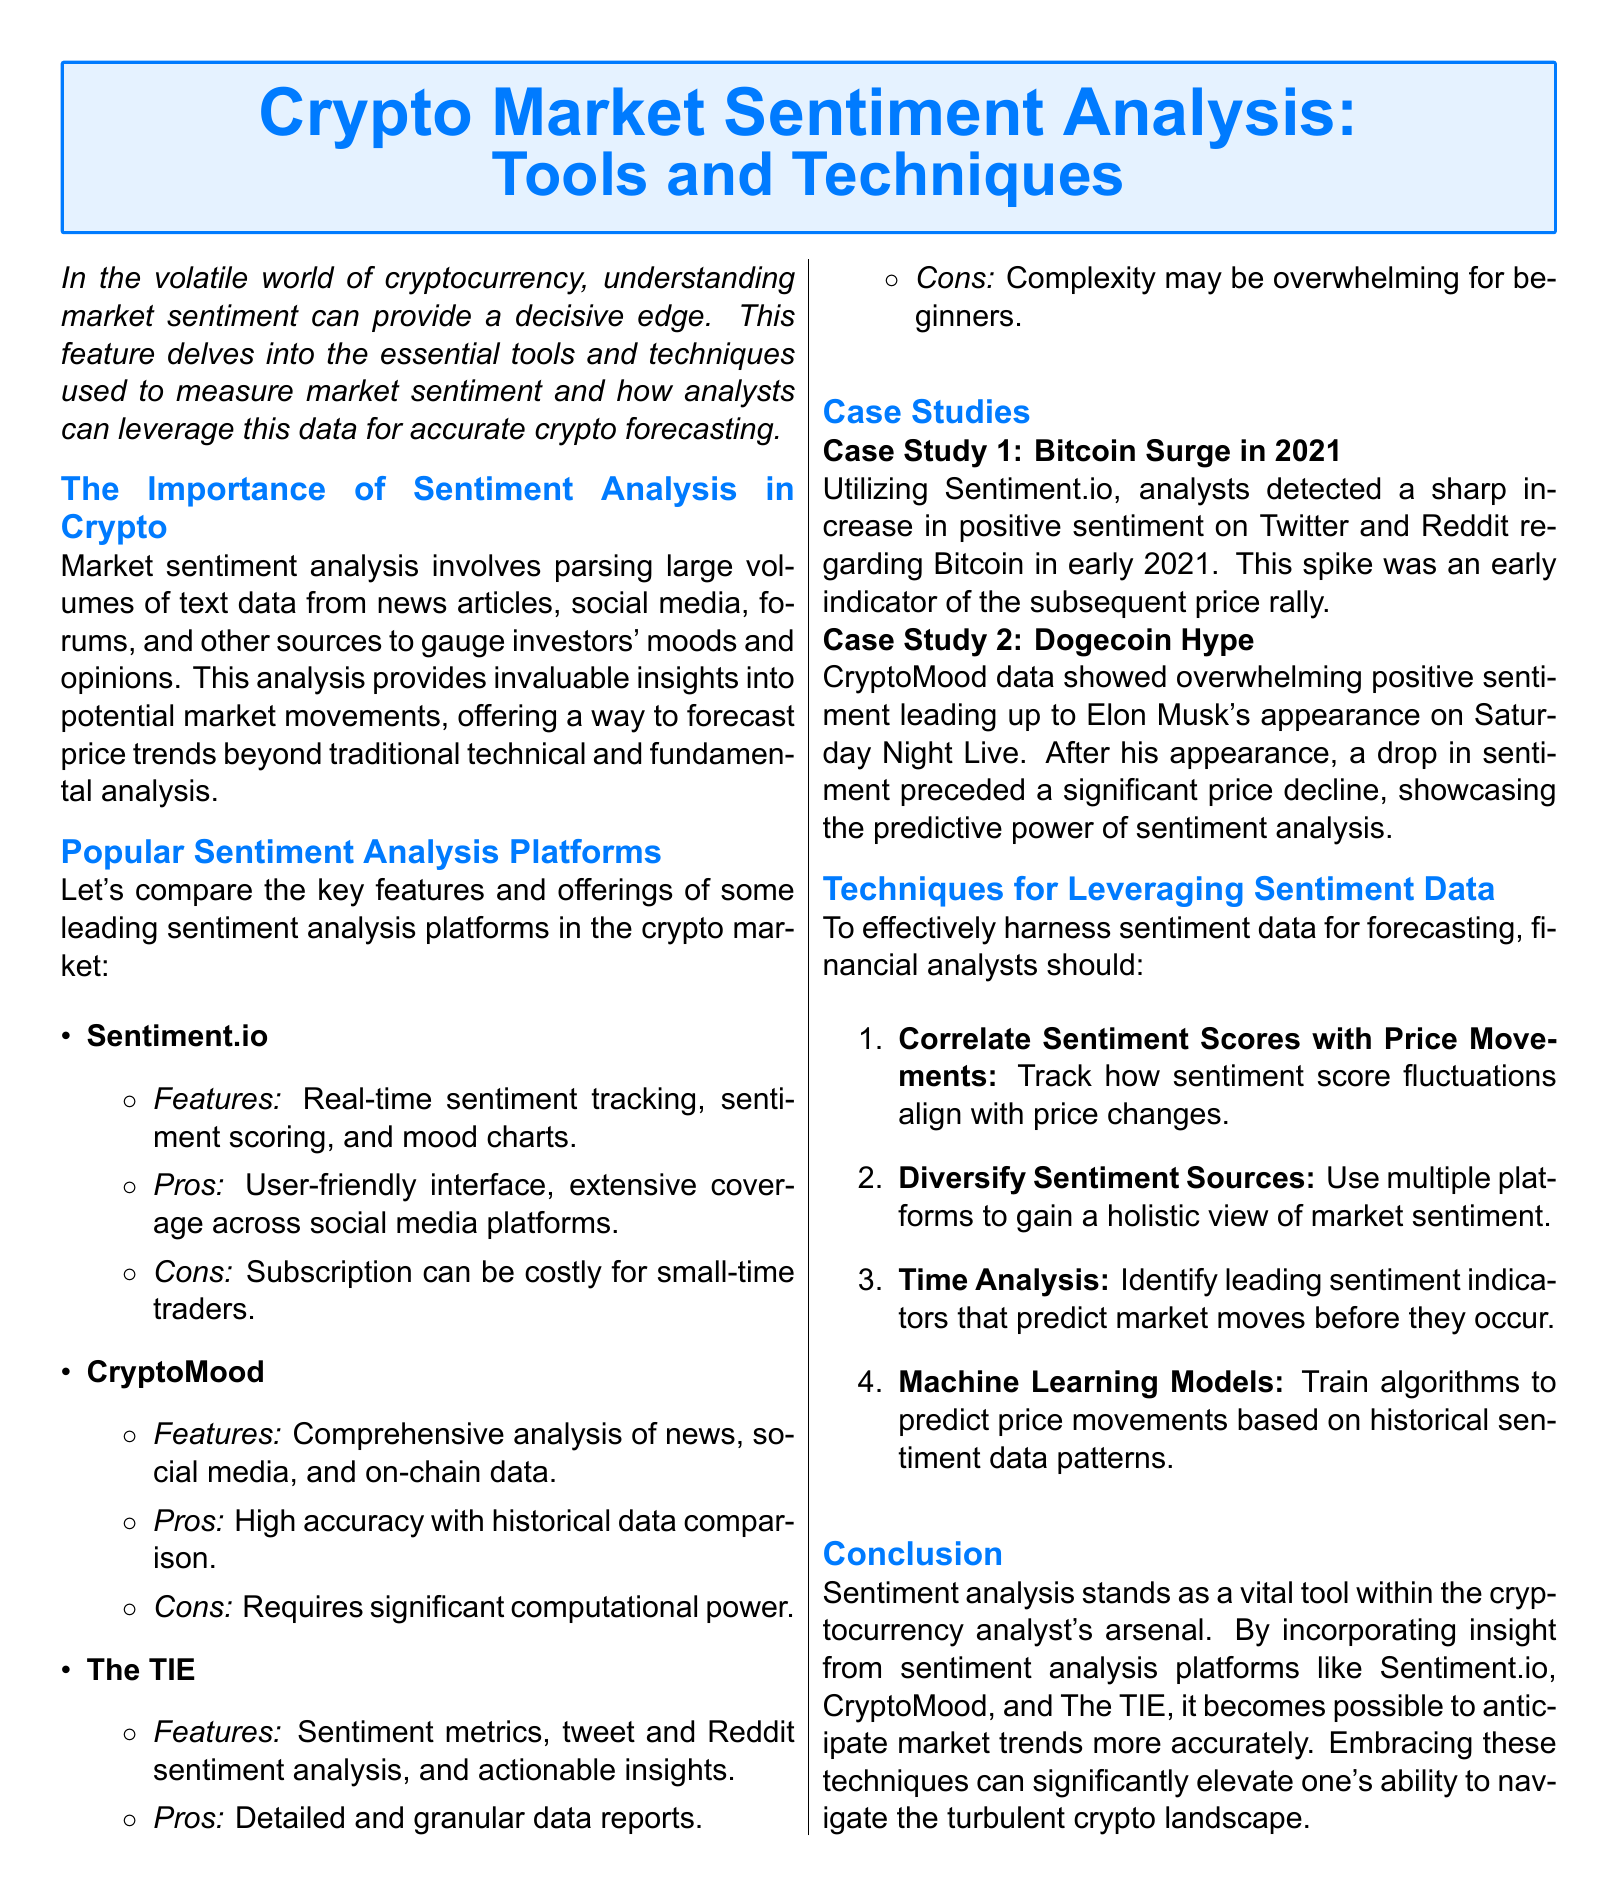What is the title of the article? The title is stated at the beginning of the document as "Crypto Market Sentiment Analysis: Tools and Techniques."
Answer: Crypto Market Sentiment Analysis: Tools and Techniques Which platform features real-time sentiment tracking? The document mentions that Sentiment.io includes real-time sentiment tracking among its features.
Answer: Sentiment.io What case study indicates a price decline after a rise in sentiment? The case study regarding Dogecoin shows a price decline after a rise in sentiment leading up to an event.
Answer: Dogecoin Hype How many techniques for leveraging sentiment data are listed? The document specifies four techniques to leverage sentiment data for better forecasting.
Answer: Four What is a significant con of using CryptoMood? The document cites the requirement for significant computational power as a con for CryptoMood.
Answer: Significant computational power Which sentiment analysis platform is described as user-friendly? Sentiment.io is described as having a user-friendly interface in the document.
Answer: Sentiment.io What sentiment analysis platform provides actionable insights? The TIE is indicated in the document to provide actionable insights among its features.
Answer: The TIE What type of analysis is emphasized as crucial for crypto analysts? The article emphasizes sentiment analysis as a vital tool for cryptocurrency analysts.
Answer: Sentiment analysis What color is used for the text background in the title box? The title background uses a light blue color defined as "cryptoblue!10" in the document.
Answer: Light blue 